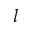<formula> <loc_0><loc_0><loc_500><loc_500>l</formula> 